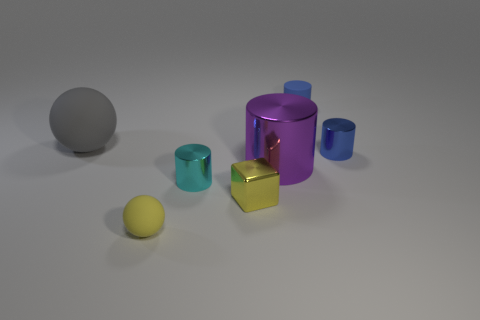Add 2 purple objects. How many objects exist? 9 Subtract all blocks. How many objects are left? 6 Add 5 tiny cyan things. How many tiny cyan things exist? 6 Subtract 1 gray balls. How many objects are left? 6 Subtract all blue shiny cylinders. Subtract all tiny yellow blocks. How many objects are left? 5 Add 7 purple shiny cylinders. How many purple shiny cylinders are left? 8 